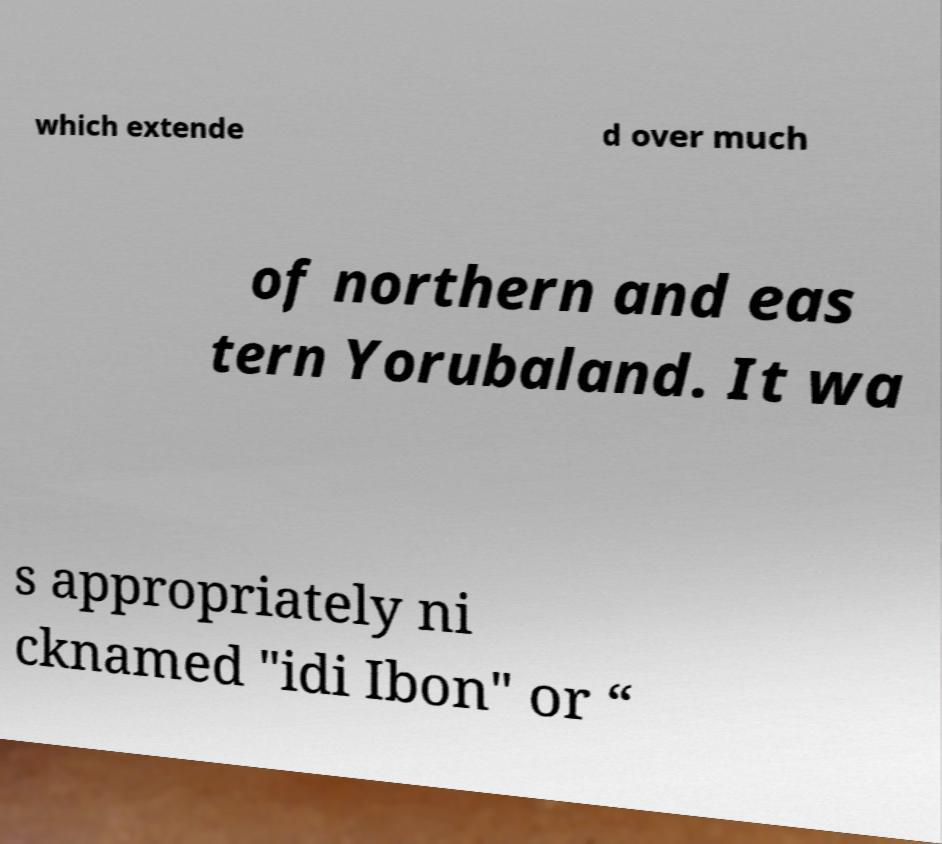I need the written content from this picture converted into text. Can you do that? which extende d over much of northern and eas tern Yorubaland. It wa s appropriately ni cknamed "idi Ibon" or “ 